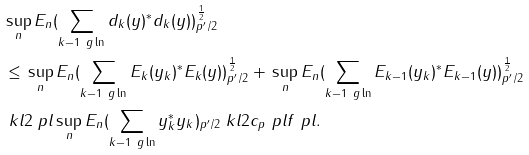Convert formula to latex. <formula><loc_0><loc_0><loc_500><loc_500>& \| \sup _ { n } E _ { n } ( \sum _ { k - 1 \ g \ln } d _ { k } ( y ) ^ { * } d _ { k } ( y ) ) \| _ { p ^ { \prime } / 2 } ^ { \frac { 1 } { 2 } } \\ & \leq \| \sup _ { n } E _ { n } ( \sum _ { k - 1 \ g \ln } E _ { k } ( y _ { k } ) ^ { * } E _ { k } ( y ) ) \| _ { p ^ { \prime } / 2 } ^ { \frac { 1 } { 2 } } + \| \sup _ { n } E _ { n } ( \sum _ { k - 1 \ g \ln } E _ { k - 1 } ( y _ { k } ) ^ { * } E _ { k - 1 } ( y ) ) \| _ { p ^ { \prime } / 2 } ^ { \frac { 1 } { 2 } } \\ & \ k l 2 \ p l \| \sup _ { n } E _ { n } ( \sum _ { k - 1 \ g \ln } y _ { k } ^ { * } y _ { k } ) \| _ { p ^ { \prime } / 2 } \ k l 2 c _ { p } \ p l \| f \| \ p l .</formula> 